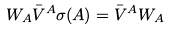<formula> <loc_0><loc_0><loc_500><loc_500>W _ { A } \bar { V } ^ { A } \sigma ( A ) = \bar { V } ^ { A } W _ { A }</formula> 